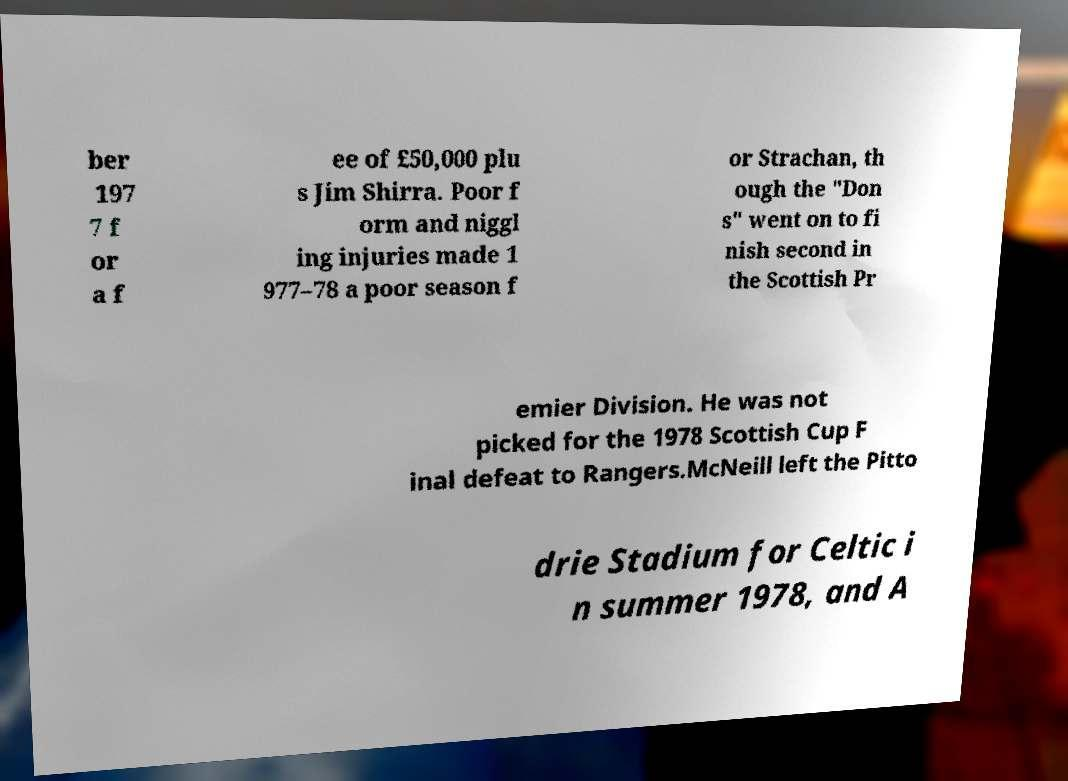Could you assist in decoding the text presented in this image and type it out clearly? ber 197 7 f or a f ee of £50,000 plu s Jim Shirra. Poor f orm and niggl ing injuries made 1 977–78 a poor season f or Strachan, th ough the "Don s" went on to fi nish second in the Scottish Pr emier Division. He was not picked for the 1978 Scottish Cup F inal defeat to Rangers.McNeill left the Pitto drie Stadium for Celtic i n summer 1978, and A 